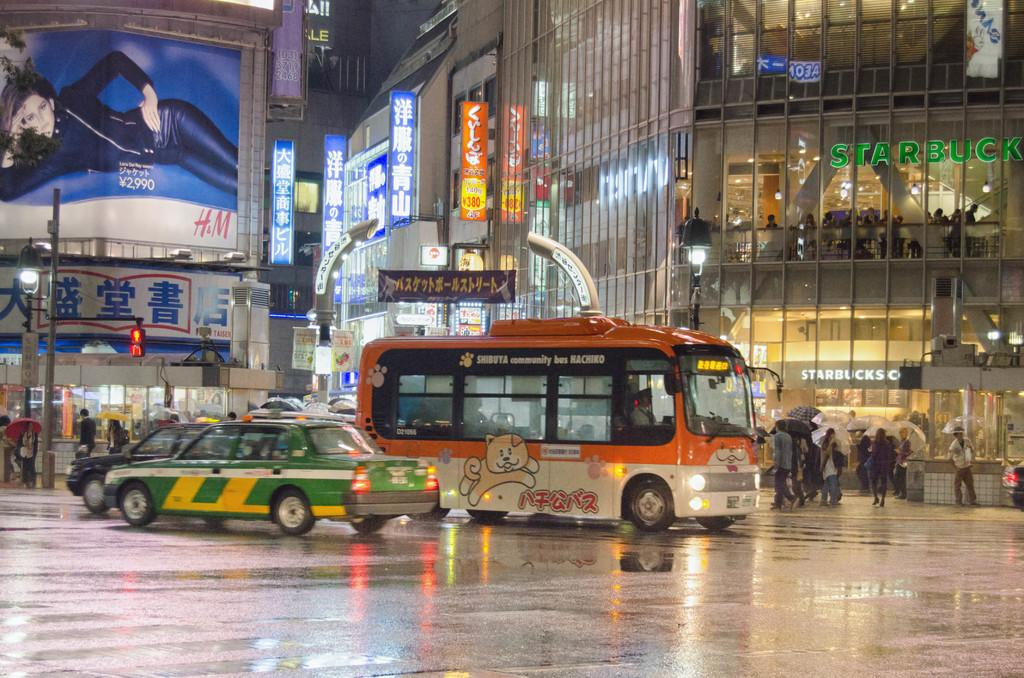<image>
Give a short and clear explanation of the subsequent image. The brand H&M that is on a billboard near 